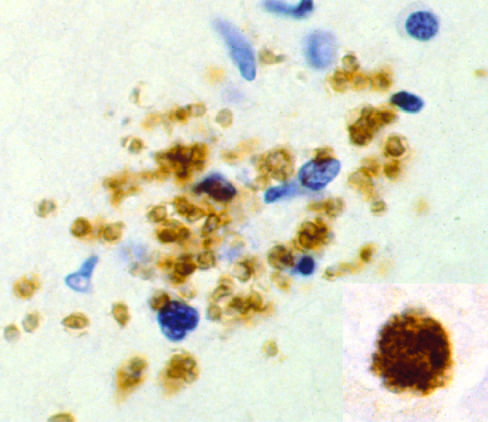what are free tachyzoites demonstrated by?
Answer the question using a single word or phrase. Immunohistochemical staining 